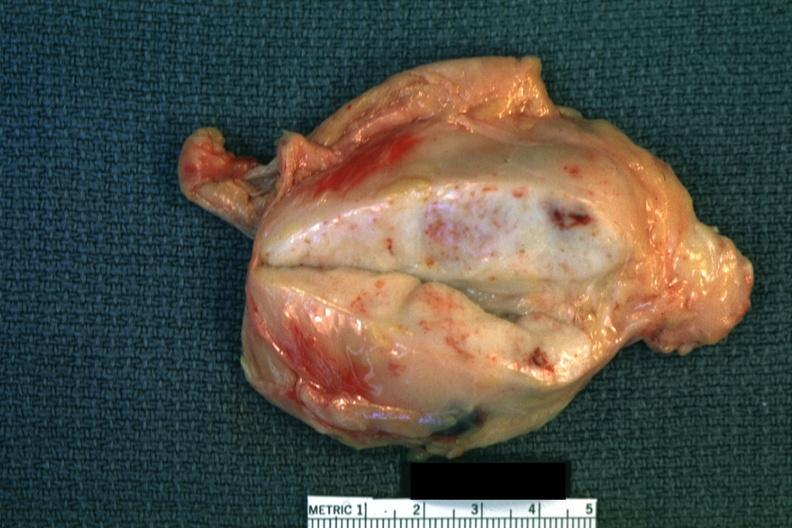what is present?
Answer the question using a single word or phrase. Lymph node 